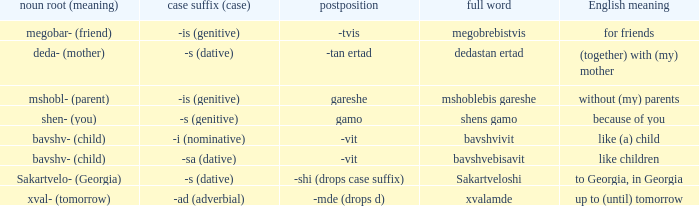What is the Full Word, when Case Suffix (case) is "-sa (dative)"? Bavshvebisavit. 